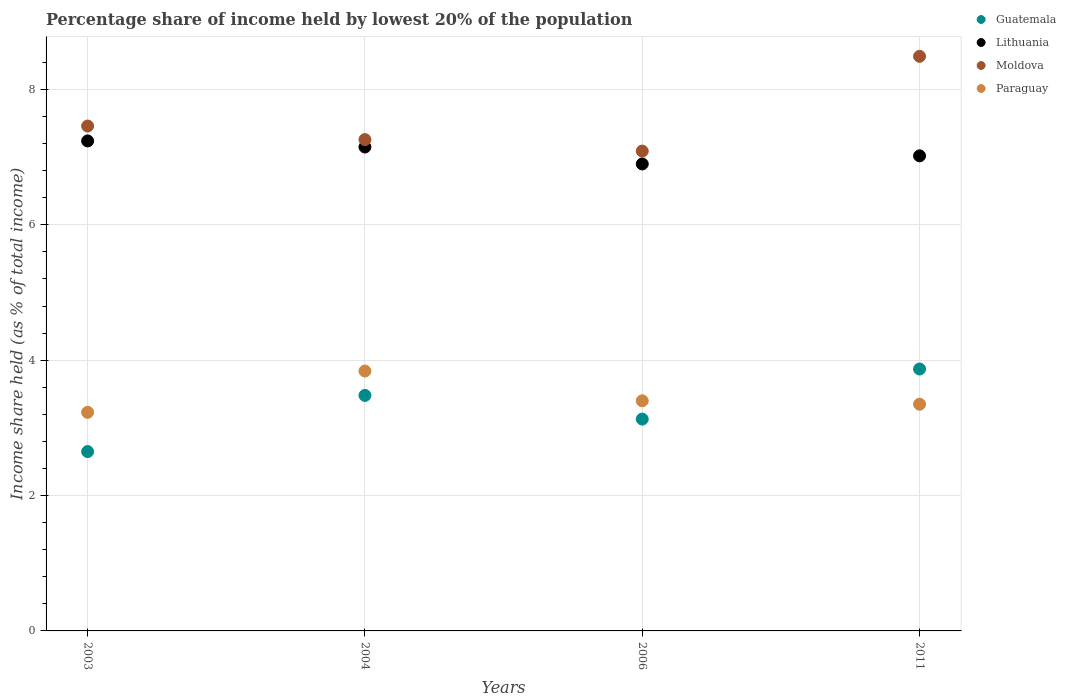How many different coloured dotlines are there?
Your answer should be very brief. 4. What is the percentage share of income held by lowest 20% of the population in Guatemala in 2003?
Offer a terse response. 2.65. Across all years, what is the maximum percentage share of income held by lowest 20% of the population in Guatemala?
Your answer should be very brief. 3.87. Across all years, what is the minimum percentage share of income held by lowest 20% of the population in Moldova?
Offer a very short reply. 7.09. In which year was the percentage share of income held by lowest 20% of the population in Paraguay minimum?
Give a very brief answer. 2003. What is the total percentage share of income held by lowest 20% of the population in Lithuania in the graph?
Your answer should be compact. 28.31. What is the difference between the percentage share of income held by lowest 20% of the population in Moldova in 2004 and that in 2011?
Offer a very short reply. -1.23. What is the difference between the percentage share of income held by lowest 20% of the population in Paraguay in 2011 and the percentage share of income held by lowest 20% of the population in Lithuania in 2003?
Give a very brief answer. -3.89. What is the average percentage share of income held by lowest 20% of the population in Moldova per year?
Provide a succinct answer. 7.57. In the year 2006, what is the difference between the percentage share of income held by lowest 20% of the population in Paraguay and percentage share of income held by lowest 20% of the population in Guatemala?
Your answer should be compact. 0.27. What is the ratio of the percentage share of income held by lowest 20% of the population in Paraguay in 2003 to that in 2004?
Ensure brevity in your answer.  0.84. Is the percentage share of income held by lowest 20% of the population in Lithuania in 2004 less than that in 2011?
Provide a succinct answer. No. What is the difference between the highest and the second highest percentage share of income held by lowest 20% of the population in Moldova?
Offer a very short reply. 1.03. What is the difference between the highest and the lowest percentage share of income held by lowest 20% of the population in Moldova?
Ensure brevity in your answer.  1.4. In how many years, is the percentage share of income held by lowest 20% of the population in Lithuania greater than the average percentage share of income held by lowest 20% of the population in Lithuania taken over all years?
Ensure brevity in your answer.  2. Is it the case that in every year, the sum of the percentage share of income held by lowest 20% of the population in Guatemala and percentage share of income held by lowest 20% of the population in Lithuania  is greater than the sum of percentage share of income held by lowest 20% of the population in Moldova and percentage share of income held by lowest 20% of the population in Paraguay?
Give a very brief answer. Yes. Is it the case that in every year, the sum of the percentage share of income held by lowest 20% of the population in Guatemala and percentage share of income held by lowest 20% of the population in Paraguay  is greater than the percentage share of income held by lowest 20% of the population in Lithuania?
Give a very brief answer. No. How many dotlines are there?
Ensure brevity in your answer.  4. What is the difference between two consecutive major ticks on the Y-axis?
Your answer should be very brief. 2. Are the values on the major ticks of Y-axis written in scientific E-notation?
Offer a very short reply. No. Does the graph contain grids?
Provide a short and direct response. Yes. What is the title of the graph?
Make the answer very short. Percentage share of income held by lowest 20% of the population. Does "Romania" appear as one of the legend labels in the graph?
Ensure brevity in your answer.  No. What is the label or title of the Y-axis?
Offer a terse response. Income share held (as % of total income). What is the Income share held (as % of total income) of Guatemala in 2003?
Offer a very short reply. 2.65. What is the Income share held (as % of total income) in Lithuania in 2003?
Give a very brief answer. 7.24. What is the Income share held (as % of total income) in Moldova in 2003?
Make the answer very short. 7.46. What is the Income share held (as % of total income) in Paraguay in 2003?
Your answer should be very brief. 3.23. What is the Income share held (as % of total income) in Guatemala in 2004?
Your response must be concise. 3.48. What is the Income share held (as % of total income) of Lithuania in 2004?
Offer a terse response. 7.15. What is the Income share held (as % of total income) in Moldova in 2004?
Keep it short and to the point. 7.26. What is the Income share held (as % of total income) of Paraguay in 2004?
Keep it short and to the point. 3.84. What is the Income share held (as % of total income) in Guatemala in 2006?
Ensure brevity in your answer.  3.13. What is the Income share held (as % of total income) of Lithuania in 2006?
Provide a succinct answer. 6.9. What is the Income share held (as % of total income) of Moldova in 2006?
Offer a terse response. 7.09. What is the Income share held (as % of total income) of Paraguay in 2006?
Your answer should be very brief. 3.4. What is the Income share held (as % of total income) of Guatemala in 2011?
Make the answer very short. 3.87. What is the Income share held (as % of total income) in Lithuania in 2011?
Provide a short and direct response. 7.02. What is the Income share held (as % of total income) in Moldova in 2011?
Keep it short and to the point. 8.49. What is the Income share held (as % of total income) in Paraguay in 2011?
Provide a short and direct response. 3.35. Across all years, what is the maximum Income share held (as % of total income) of Guatemala?
Your response must be concise. 3.87. Across all years, what is the maximum Income share held (as % of total income) in Lithuania?
Provide a succinct answer. 7.24. Across all years, what is the maximum Income share held (as % of total income) of Moldova?
Keep it short and to the point. 8.49. Across all years, what is the maximum Income share held (as % of total income) of Paraguay?
Keep it short and to the point. 3.84. Across all years, what is the minimum Income share held (as % of total income) in Guatemala?
Make the answer very short. 2.65. Across all years, what is the minimum Income share held (as % of total income) of Moldova?
Offer a very short reply. 7.09. Across all years, what is the minimum Income share held (as % of total income) of Paraguay?
Give a very brief answer. 3.23. What is the total Income share held (as % of total income) of Guatemala in the graph?
Your response must be concise. 13.13. What is the total Income share held (as % of total income) of Lithuania in the graph?
Provide a short and direct response. 28.31. What is the total Income share held (as % of total income) of Moldova in the graph?
Your answer should be very brief. 30.3. What is the total Income share held (as % of total income) in Paraguay in the graph?
Your answer should be compact. 13.82. What is the difference between the Income share held (as % of total income) of Guatemala in 2003 and that in 2004?
Offer a very short reply. -0.83. What is the difference between the Income share held (as % of total income) of Lithuania in 2003 and that in 2004?
Your answer should be very brief. 0.09. What is the difference between the Income share held (as % of total income) in Paraguay in 2003 and that in 2004?
Provide a succinct answer. -0.61. What is the difference between the Income share held (as % of total income) in Guatemala in 2003 and that in 2006?
Provide a succinct answer. -0.48. What is the difference between the Income share held (as % of total income) of Lithuania in 2003 and that in 2006?
Your answer should be compact. 0.34. What is the difference between the Income share held (as % of total income) in Moldova in 2003 and that in 2006?
Provide a succinct answer. 0.37. What is the difference between the Income share held (as % of total income) of Paraguay in 2003 and that in 2006?
Ensure brevity in your answer.  -0.17. What is the difference between the Income share held (as % of total income) of Guatemala in 2003 and that in 2011?
Offer a terse response. -1.22. What is the difference between the Income share held (as % of total income) of Lithuania in 2003 and that in 2011?
Offer a terse response. 0.22. What is the difference between the Income share held (as % of total income) in Moldova in 2003 and that in 2011?
Make the answer very short. -1.03. What is the difference between the Income share held (as % of total income) in Paraguay in 2003 and that in 2011?
Your answer should be compact. -0.12. What is the difference between the Income share held (as % of total income) of Lithuania in 2004 and that in 2006?
Offer a terse response. 0.25. What is the difference between the Income share held (as % of total income) in Moldova in 2004 and that in 2006?
Provide a short and direct response. 0.17. What is the difference between the Income share held (as % of total income) of Paraguay in 2004 and that in 2006?
Provide a short and direct response. 0.44. What is the difference between the Income share held (as % of total income) in Guatemala in 2004 and that in 2011?
Your answer should be very brief. -0.39. What is the difference between the Income share held (as % of total income) in Lithuania in 2004 and that in 2011?
Keep it short and to the point. 0.13. What is the difference between the Income share held (as % of total income) of Moldova in 2004 and that in 2011?
Give a very brief answer. -1.23. What is the difference between the Income share held (as % of total income) in Paraguay in 2004 and that in 2011?
Provide a succinct answer. 0.49. What is the difference between the Income share held (as % of total income) of Guatemala in 2006 and that in 2011?
Offer a terse response. -0.74. What is the difference between the Income share held (as % of total income) in Lithuania in 2006 and that in 2011?
Provide a succinct answer. -0.12. What is the difference between the Income share held (as % of total income) in Moldova in 2006 and that in 2011?
Your answer should be very brief. -1.4. What is the difference between the Income share held (as % of total income) of Paraguay in 2006 and that in 2011?
Keep it short and to the point. 0.05. What is the difference between the Income share held (as % of total income) in Guatemala in 2003 and the Income share held (as % of total income) in Moldova in 2004?
Your answer should be very brief. -4.61. What is the difference between the Income share held (as % of total income) in Guatemala in 2003 and the Income share held (as % of total income) in Paraguay in 2004?
Offer a very short reply. -1.19. What is the difference between the Income share held (as % of total income) of Lithuania in 2003 and the Income share held (as % of total income) of Moldova in 2004?
Keep it short and to the point. -0.02. What is the difference between the Income share held (as % of total income) of Moldova in 2003 and the Income share held (as % of total income) of Paraguay in 2004?
Your answer should be compact. 3.62. What is the difference between the Income share held (as % of total income) of Guatemala in 2003 and the Income share held (as % of total income) of Lithuania in 2006?
Offer a very short reply. -4.25. What is the difference between the Income share held (as % of total income) of Guatemala in 2003 and the Income share held (as % of total income) of Moldova in 2006?
Provide a succinct answer. -4.44. What is the difference between the Income share held (as % of total income) in Guatemala in 2003 and the Income share held (as % of total income) in Paraguay in 2006?
Ensure brevity in your answer.  -0.75. What is the difference between the Income share held (as % of total income) in Lithuania in 2003 and the Income share held (as % of total income) in Paraguay in 2006?
Keep it short and to the point. 3.84. What is the difference between the Income share held (as % of total income) in Moldova in 2003 and the Income share held (as % of total income) in Paraguay in 2006?
Ensure brevity in your answer.  4.06. What is the difference between the Income share held (as % of total income) in Guatemala in 2003 and the Income share held (as % of total income) in Lithuania in 2011?
Provide a short and direct response. -4.37. What is the difference between the Income share held (as % of total income) in Guatemala in 2003 and the Income share held (as % of total income) in Moldova in 2011?
Offer a very short reply. -5.84. What is the difference between the Income share held (as % of total income) of Guatemala in 2003 and the Income share held (as % of total income) of Paraguay in 2011?
Keep it short and to the point. -0.7. What is the difference between the Income share held (as % of total income) of Lithuania in 2003 and the Income share held (as % of total income) of Moldova in 2011?
Provide a short and direct response. -1.25. What is the difference between the Income share held (as % of total income) in Lithuania in 2003 and the Income share held (as % of total income) in Paraguay in 2011?
Provide a succinct answer. 3.89. What is the difference between the Income share held (as % of total income) of Moldova in 2003 and the Income share held (as % of total income) of Paraguay in 2011?
Make the answer very short. 4.11. What is the difference between the Income share held (as % of total income) in Guatemala in 2004 and the Income share held (as % of total income) in Lithuania in 2006?
Offer a very short reply. -3.42. What is the difference between the Income share held (as % of total income) in Guatemala in 2004 and the Income share held (as % of total income) in Moldova in 2006?
Ensure brevity in your answer.  -3.61. What is the difference between the Income share held (as % of total income) in Lithuania in 2004 and the Income share held (as % of total income) in Paraguay in 2006?
Your answer should be compact. 3.75. What is the difference between the Income share held (as % of total income) of Moldova in 2004 and the Income share held (as % of total income) of Paraguay in 2006?
Your answer should be compact. 3.86. What is the difference between the Income share held (as % of total income) of Guatemala in 2004 and the Income share held (as % of total income) of Lithuania in 2011?
Make the answer very short. -3.54. What is the difference between the Income share held (as % of total income) of Guatemala in 2004 and the Income share held (as % of total income) of Moldova in 2011?
Keep it short and to the point. -5.01. What is the difference between the Income share held (as % of total income) in Guatemala in 2004 and the Income share held (as % of total income) in Paraguay in 2011?
Ensure brevity in your answer.  0.13. What is the difference between the Income share held (as % of total income) of Lithuania in 2004 and the Income share held (as % of total income) of Moldova in 2011?
Offer a very short reply. -1.34. What is the difference between the Income share held (as % of total income) in Lithuania in 2004 and the Income share held (as % of total income) in Paraguay in 2011?
Your answer should be very brief. 3.8. What is the difference between the Income share held (as % of total income) of Moldova in 2004 and the Income share held (as % of total income) of Paraguay in 2011?
Your response must be concise. 3.91. What is the difference between the Income share held (as % of total income) in Guatemala in 2006 and the Income share held (as % of total income) in Lithuania in 2011?
Ensure brevity in your answer.  -3.89. What is the difference between the Income share held (as % of total income) in Guatemala in 2006 and the Income share held (as % of total income) in Moldova in 2011?
Make the answer very short. -5.36. What is the difference between the Income share held (as % of total income) in Guatemala in 2006 and the Income share held (as % of total income) in Paraguay in 2011?
Ensure brevity in your answer.  -0.22. What is the difference between the Income share held (as % of total income) in Lithuania in 2006 and the Income share held (as % of total income) in Moldova in 2011?
Make the answer very short. -1.59. What is the difference between the Income share held (as % of total income) in Lithuania in 2006 and the Income share held (as % of total income) in Paraguay in 2011?
Your answer should be compact. 3.55. What is the difference between the Income share held (as % of total income) of Moldova in 2006 and the Income share held (as % of total income) of Paraguay in 2011?
Provide a short and direct response. 3.74. What is the average Income share held (as % of total income) in Guatemala per year?
Offer a terse response. 3.28. What is the average Income share held (as % of total income) of Lithuania per year?
Provide a short and direct response. 7.08. What is the average Income share held (as % of total income) in Moldova per year?
Offer a very short reply. 7.58. What is the average Income share held (as % of total income) in Paraguay per year?
Keep it short and to the point. 3.46. In the year 2003, what is the difference between the Income share held (as % of total income) of Guatemala and Income share held (as % of total income) of Lithuania?
Provide a short and direct response. -4.59. In the year 2003, what is the difference between the Income share held (as % of total income) in Guatemala and Income share held (as % of total income) in Moldova?
Your answer should be very brief. -4.81. In the year 2003, what is the difference between the Income share held (as % of total income) of Guatemala and Income share held (as % of total income) of Paraguay?
Keep it short and to the point. -0.58. In the year 2003, what is the difference between the Income share held (as % of total income) in Lithuania and Income share held (as % of total income) in Moldova?
Your answer should be very brief. -0.22. In the year 2003, what is the difference between the Income share held (as % of total income) of Lithuania and Income share held (as % of total income) of Paraguay?
Provide a short and direct response. 4.01. In the year 2003, what is the difference between the Income share held (as % of total income) of Moldova and Income share held (as % of total income) of Paraguay?
Your answer should be very brief. 4.23. In the year 2004, what is the difference between the Income share held (as % of total income) in Guatemala and Income share held (as % of total income) in Lithuania?
Provide a succinct answer. -3.67. In the year 2004, what is the difference between the Income share held (as % of total income) of Guatemala and Income share held (as % of total income) of Moldova?
Provide a succinct answer. -3.78. In the year 2004, what is the difference between the Income share held (as % of total income) of Guatemala and Income share held (as % of total income) of Paraguay?
Provide a short and direct response. -0.36. In the year 2004, what is the difference between the Income share held (as % of total income) in Lithuania and Income share held (as % of total income) in Moldova?
Keep it short and to the point. -0.11. In the year 2004, what is the difference between the Income share held (as % of total income) of Lithuania and Income share held (as % of total income) of Paraguay?
Keep it short and to the point. 3.31. In the year 2004, what is the difference between the Income share held (as % of total income) in Moldova and Income share held (as % of total income) in Paraguay?
Offer a terse response. 3.42. In the year 2006, what is the difference between the Income share held (as % of total income) in Guatemala and Income share held (as % of total income) in Lithuania?
Offer a terse response. -3.77. In the year 2006, what is the difference between the Income share held (as % of total income) in Guatemala and Income share held (as % of total income) in Moldova?
Keep it short and to the point. -3.96. In the year 2006, what is the difference between the Income share held (as % of total income) in Guatemala and Income share held (as % of total income) in Paraguay?
Provide a short and direct response. -0.27. In the year 2006, what is the difference between the Income share held (as % of total income) in Lithuania and Income share held (as % of total income) in Moldova?
Keep it short and to the point. -0.19. In the year 2006, what is the difference between the Income share held (as % of total income) of Moldova and Income share held (as % of total income) of Paraguay?
Ensure brevity in your answer.  3.69. In the year 2011, what is the difference between the Income share held (as % of total income) of Guatemala and Income share held (as % of total income) of Lithuania?
Keep it short and to the point. -3.15. In the year 2011, what is the difference between the Income share held (as % of total income) of Guatemala and Income share held (as % of total income) of Moldova?
Your answer should be compact. -4.62. In the year 2011, what is the difference between the Income share held (as % of total income) in Guatemala and Income share held (as % of total income) in Paraguay?
Your response must be concise. 0.52. In the year 2011, what is the difference between the Income share held (as % of total income) of Lithuania and Income share held (as % of total income) of Moldova?
Ensure brevity in your answer.  -1.47. In the year 2011, what is the difference between the Income share held (as % of total income) in Lithuania and Income share held (as % of total income) in Paraguay?
Offer a terse response. 3.67. In the year 2011, what is the difference between the Income share held (as % of total income) in Moldova and Income share held (as % of total income) in Paraguay?
Your answer should be compact. 5.14. What is the ratio of the Income share held (as % of total income) in Guatemala in 2003 to that in 2004?
Your answer should be very brief. 0.76. What is the ratio of the Income share held (as % of total income) in Lithuania in 2003 to that in 2004?
Offer a very short reply. 1.01. What is the ratio of the Income share held (as % of total income) in Moldova in 2003 to that in 2004?
Your response must be concise. 1.03. What is the ratio of the Income share held (as % of total income) of Paraguay in 2003 to that in 2004?
Provide a succinct answer. 0.84. What is the ratio of the Income share held (as % of total income) of Guatemala in 2003 to that in 2006?
Provide a succinct answer. 0.85. What is the ratio of the Income share held (as % of total income) in Lithuania in 2003 to that in 2006?
Your answer should be compact. 1.05. What is the ratio of the Income share held (as % of total income) in Moldova in 2003 to that in 2006?
Your answer should be very brief. 1.05. What is the ratio of the Income share held (as % of total income) in Paraguay in 2003 to that in 2006?
Keep it short and to the point. 0.95. What is the ratio of the Income share held (as % of total income) of Guatemala in 2003 to that in 2011?
Provide a short and direct response. 0.68. What is the ratio of the Income share held (as % of total income) of Lithuania in 2003 to that in 2011?
Offer a very short reply. 1.03. What is the ratio of the Income share held (as % of total income) in Moldova in 2003 to that in 2011?
Your answer should be compact. 0.88. What is the ratio of the Income share held (as % of total income) of Paraguay in 2003 to that in 2011?
Make the answer very short. 0.96. What is the ratio of the Income share held (as % of total income) in Guatemala in 2004 to that in 2006?
Keep it short and to the point. 1.11. What is the ratio of the Income share held (as % of total income) of Lithuania in 2004 to that in 2006?
Make the answer very short. 1.04. What is the ratio of the Income share held (as % of total income) in Paraguay in 2004 to that in 2006?
Ensure brevity in your answer.  1.13. What is the ratio of the Income share held (as % of total income) in Guatemala in 2004 to that in 2011?
Provide a succinct answer. 0.9. What is the ratio of the Income share held (as % of total income) in Lithuania in 2004 to that in 2011?
Your answer should be very brief. 1.02. What is the ratio of the Income share held (as % of total income) of Moldova in 2004 to that in 2011?
Your response must be concise. 0.86. What is the ratio of the Income share held (as % of total income) of Paraguay in 2004 to that in 2011?
Provide a short and direct response. 1.15. What is the ratio of the Income share held (as % of total income) of Guatemala in 2006 to that in 2011?
Your answer should be very brief. 0.81. What is the ratio of the Income share held (as % of total income) of Lithuania in 2006 to that in 2011?
Your answer should be compact. 0.98. What is the ratio of the Income share held (as % of total income) in Moldova in 2006 to that in 2011?
Give a very brief answer. 0.84. What is the ratio of the Income share held (as % of total income) of Paraguay in 2006 to that in 2011?
Offer a very short reply. 1.01. What is the difference between the highest and the second highest Income share held (as % of total income) of Guatemala?
Give a very brief answer. 0.39. What is the difference between the highest and the second highest Income share held (as % of total income) of Lithuania?
Give a very brief answer. 0.09. What is the difference between the highest and the second highest Income share held (as % of total income) of Moldova?
Give a very brief answer. 1.03. What is the difference between the highest and the second highest Income share held (as % of total income) in Paraguay?
Provide a short and direct response. 0.44. What is the difference between the highest and the lowest Income share held (as % of total income) in Guatemala?
Provide a succinct answer. 1.22. What is the difference between the highest and the lowest Income share held (as % of total income) of Lithuania?
Offer a very short reply. 0.34. What is the difference between the highest and the lowest Income share held (as % of total income) of Moldova?
Make the answer very short. 1.4. What is the difference between the highest and the lowest Income share held (as % of total income) in Paraguay?
Make the answer very short. 0.61. 